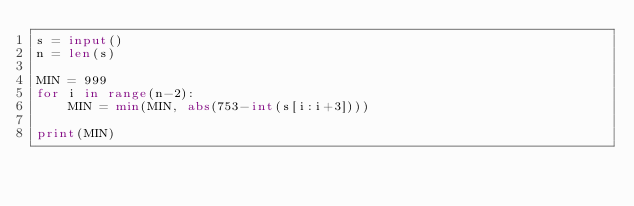<code> <loc_0><loc_0><loc_500><loc_500><_Python_>s = input()
n = len(s)

MIN = 999
for i in range(n-2):
    MIN = min(MIN, abs(753-int(s[i:i+3])))

print(MIN)</code> 